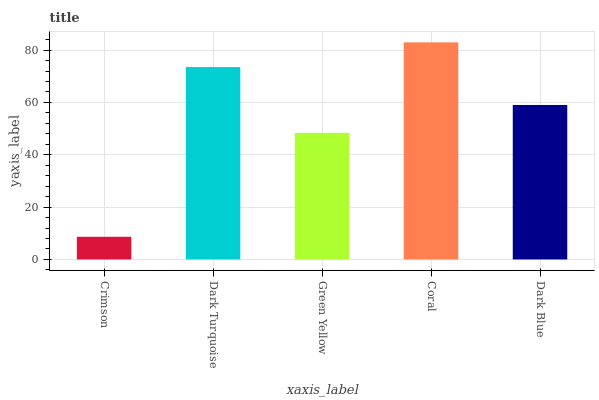Is Crimson the minimum?
Answer yes or no. Yes. Is Coral the maximum?
Answer yes or no. Yes. Is Dark Turquoise the minimum?
Answer yes or no. No. Is Dark Turquoise the maximum?
Answer yes or no. No. Is Dark Turquoise greater than Crimson?
Answer yes or no. Yes. Is Crimson less than Dark Turquoise?
Answer yes or no. Yes. Is Crimson greater than Dark Turquoise?
Answer yes or no. No. Is Dark Turquoise less than Crimson?
Answer yes or no. No. Is Dark Blue the high median?
Answer yes or no. Yes. Is Dark Blue the low median?
Answer yes or no. Yes. Is Crimson the high median?
Answer yes or no. No. Is Dark Turquoise the low median?
Answer yes or no. No. 